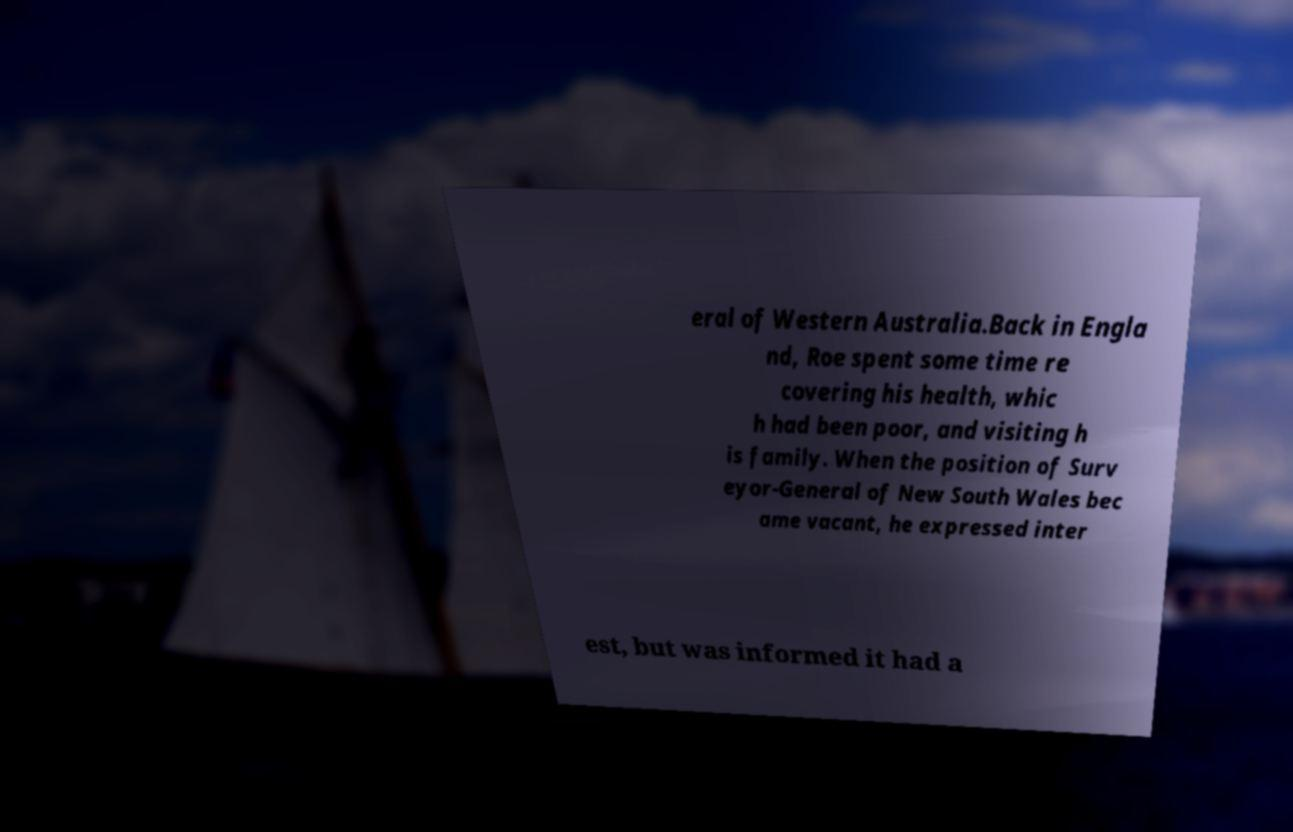There's text embedded in this image that I need extracted. Can you transcribe it verbatim? eral of Western Australia.Back in Engla nd, Roe spent some time re covering his health, whic h had been poor, and visiting h is family. When the position of Surv eyor-General of New South Wales bec ame vacant, he expressed inter est, but was informed it had a 